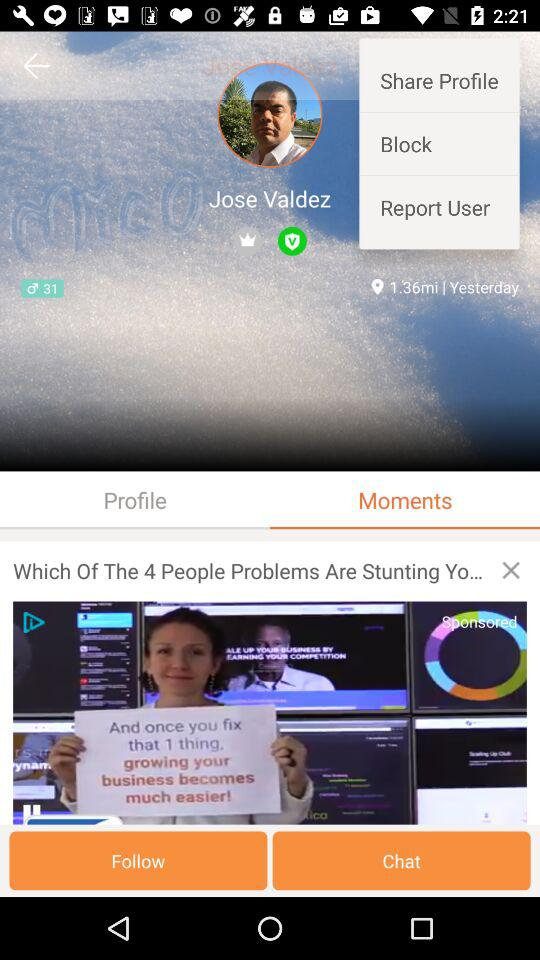What is the distance in miles shown on the screen? The distance shown is 1.36 miles. 